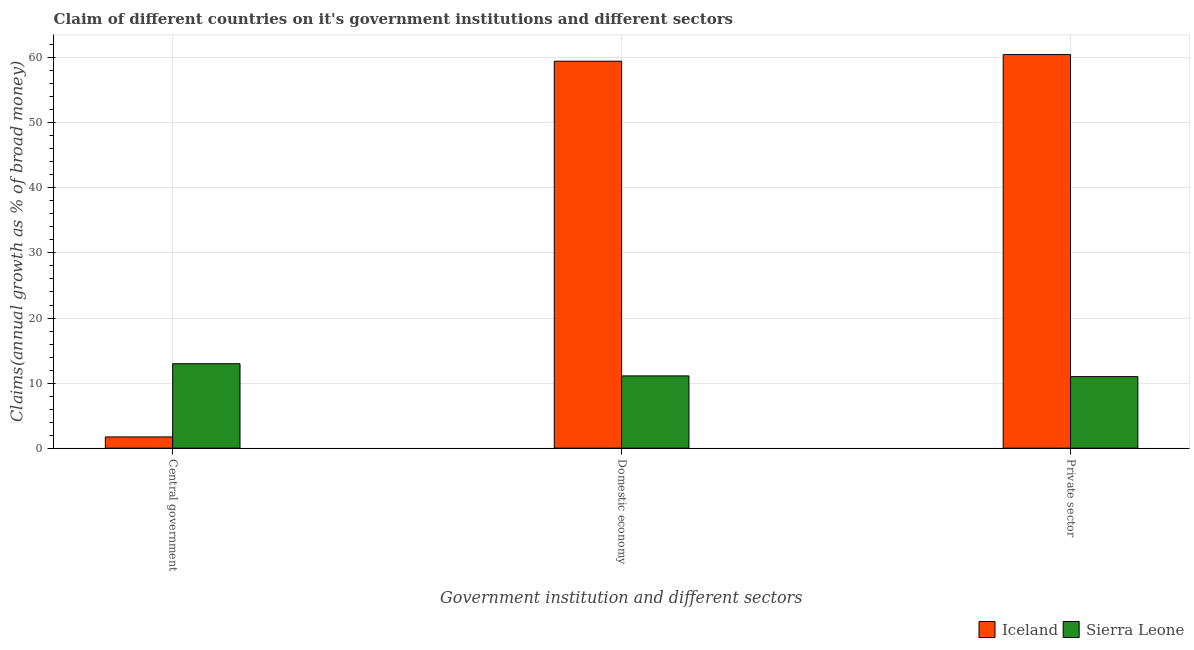How many different coloured bars are there?
Offer a very short reply. 2. Are the number of bars per tick equal to the number of legend labels?
Make the answer very short. Yes. Are the number of bars on each tick of the X-axis equal?
Keep it short and to the point. Yes. How many bars are there on the 3rd tick from the right?
Give a very brief answer. 2. What is the label of the 3rd group of bars from the left?
Provide a succinct answer. Private sector. What is the percentage of claim on the central government in Sierra Leone?
Make the answer very short. 12.98. Across all countries, what is the maximum percentage of claim on the central government?
Your answer should be compact. 12.98. Across all countries, what is the minimum percentage of claim on the central government?
Make the answer very short. 1.73. In which country was the percentage of claim on the central government maximum?
Your response must be concise. Sierra Leone. In which country was the percentage of claim on the private sector minimum?
Your answer should be very brief. Sierra Leone. What is the total percentage of claim on the central government in the graph?
Make the answer very short. 14.7. What is the difference between the percentage of claim on the central government in Iceland and that in Sierra Leone?
Provide a succinct answer. -11.25. What is the difference between the percentage of claim on the central government in Iceland and the percentage of claim on the private sector in Sierra Leone?
Give a very brief answer. -9.27. What is the average percentage of claim on the central government per country?
Offer a very short reply. 7.35. What is the difference between the percentage of claim on the central government and percentage of claim on the domestic economy in Iceland?
Ensure brevity in your answer.  -57.74. In how many countries, is the percentage of claim on the domestic economy greater than 50 %?
Keep it short and to the point. 1. What is the ratio of the percentage of claim on the central government in Sierra Leone to that in Iceland?
Your answer should be compact. 7.52. Is the percentage of claim on the private sector in Sierra Leone less than that in Iceland?
Offer a terse response. Yes. What is the difference between the highest and the second highest percentage of claim on the central government?
Your response must be concise. 11.25. What is the difference between the highest and the lowest percentage of claim on the central government?
Make the answer very short. 11.25. Is the sum of the percentage of claim on the private sector in Iceland and Sierra Leone greater than the maximum percentage of claim on the central government across all countries?
Offer a terse response. Yes. What does the 2nd bar from the left in Central government represents?
Offer a terse response. Sierra Leone. What does the 1st bar from the right in Domestic economy represents?
Your answer should be compact. Sierra Leone. Is it the case that in every country, the sum of the percentage of claim on the central government and percentage of claim on the domestic economy is greater than the percentage of claim on the private sector?
Offer a terse response. Yes. How many countries are there in the graph?
Make the answer very short. 2. Are the values on the major ticks of Y-axis written in scientific E-notation?
Make the answer very short. No. How many legend labels are there?
Ensure brevity in your answer.  2. What is the title of the graph?
Your answer should be very brief. Claim of different countries on it's government institutions and different sectors. Does "Yemen, Rep." appear as one of the legend labels in the graph?
Ensure brevity in your answer.  No. What is the label or title of the X-axis?
Your answer should be compact. Government institution and different sectors. What is the label or title of the Y-axis?
Provide a succinct answer. Claims(annual growth as % of broad money). What is the Claims(annual growth as % of broad money) of Iceland in Central government?
Keep it short and to the point. 1.73. What is the Claims(annual growth as % of broad money) of Sierra Leone in Central government?
Offer a very short reply. 12.98. What is the Claims(annual growth as % of broad money) of Iceland in Domestic economy?
Make the answer very short. 59.47. What is the Claims(annual growth as % of broad money) in Sierra Leone in Domestic economy?
Your answer should be very brief. 11.1. What is the Claims(annual growth as % of broad money) of Iceland in Private sector?
Provide a short and direct response. 60.49. What is the Claims(annual growth as % of broad money) in Sierra Leone in Private sector?
Provide a succinct answer. 10.99. Across all Government institution and different sectors, what is the maximum Claims(annual growth as % of broad money) of Iceland?
Make the answer very short. 60.49. Across all Government institution and different sectors, what is the maximum Claims(annual growth as % of broad money) of Sierra Leone?
Provide a short and direct response. 12.98. Across all Government institution and different sectors, what is the minimum Claims(annual growth as % of broad money) in Iceland?
Offer a terse response. 1.73. Across all Government institution and different sectors, what is the minimum Claims(annual growth as % of broad money) of Sierra Leone?
Your answer should be very brief. 10.99. What is the total Claims(annual growth as % of broad money) of Iceland in the graph?
Your response must be concise. 121.68. What is the total Claims(annual growth as % of broad money) in Sierra Leone in the graph?
Your answer should be very brief. 35.07. What is the difference between the Claims(annual growth as % of broad money) of Iceland in Central government and that in Domestic economy?
Your answer should be compact. -57.74. What is the difference between the Claims(annual growth as % of broad money) in Sierra Leone in Central government and that in Domestic economy?
Make the answer very short. 1.87. What is the difference between the Claims(annual growth as % of broad money) in Iceland in Central government and that in Private sector?
Provide a short and direct response. -58.76. What is the difference between the Claims(annual growth as % of broad money) in Sierra Leone in Central government and that in Private sector?
Offer a terse response. 1.99. What is the difference between the Claims(annual growth as % of broad money) in Iceland in Domestic economy and that in Private sector?
Offer a terse response. -1.02. What is the difference between the Claims(annual growth as % of broad money) of Sierra Leone in Domestic economy and that in Private sector?
Offer a very short reply. 0.11. What is the difference between the Claims(annual growth as % of broad money) in Iceland in Central government and the Claims(annual growth as % of broad money) in Sierra Leone in Domestic economy?
Keep it short and to the point. -9.38. What is the difference between the Claims(annual growth as % of broad money) of Iceland in Central government and the Claims(annual growth as % of broad money) of Sierra Leone in Private sector?
Provide a succinct answer. -9.27. What is the difference between the Claims(annual growth as % of broad money) in Iceland in Domestic economy and the Claims(annual growth as % of broad money) in Sierra Leone in Private sector?
Make the answer very short. 48.47. What is the average Claims(annual growth as % of broad money) in Iceland per Government institution and different sectors?
Provide a succinct answer. 40.56. What is the average Claims(annual growth as % of broad money) of Sierra Leone per Government institution and different sectors?
Ensure brevity in your answer.  11.69. What is the difference between the Claims(annual growth as % of broad money) of Iceland and Claims(annual growth as % of broad money) of Sierra Leone in Central government?
Provide a short and direct response. -11.25. What is the difference between the Claims(annual growth as % of broad money) in Iceland and Claims(annual growth as % of broad money) in Sierra Leone in Domestic economy?
Offer a terse response. 48.36. What is the difference between the Claims(annual growth as % of broad money) in Iceland and Claims(annual growth as % of broad money) in Sierra Leone in Private sector?
Your answer should be very brief. 49.5. What is the ratio of the Claims(annual growth as % of broad money) of Iceland in Central government to that in Domestic economy?
Give a very brief answer. 0.03. What is the ratio of the Claims(annual growth as % of broad money) in Sierra Leone in Central government to that in Domestic economy?
Offer a terse response. 1.17. What is the ratio of the Claims(annual growth as % of broad money) in Iceland in Central government to that in Private sector?
Your response must be concise. 0.03. What is the ratio of the Claims(annual growth as % of broad money) of Sierra Leone in Central government to that in Private sector?
Your answer should be compact. 1.18. What is the ratio of the Claims(annual growth as % of broad money) in Iceland in Domestic economy to that in Private sector?
Make the answer very short. 0.98. What is the ratio of the Claims(annual growth as % of broad money) in Sierra Leone in Domestic economy to that in Private sector?
Keep it short and to the point. 1.01. What is the difference between the highest and the second highest Claims(annual growth as % of broad money) in Iceland?
Your response must be concise. 1.02. What is the difference between the highest and the second highest Claims(annual growth as % of broad money) of Sierra Leone?
Make the answer very short. 1.87. What is the difference between the highest and the lowest Claims(annual growth as % of broad money) of Iceland?
Provide a succinct answer. 58.76. What is the difference between the highest and the lowest Claims(annual growth as % of broad money) in Sierra Leone?
Offer a very short reply. 1.99. 